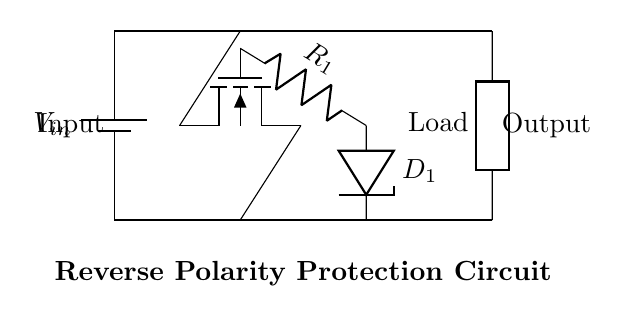What components are used in this circuit? The circuit includes a battery, an N-channel MOSFET (with no body diode), a resistor, a Zener diode, and a generic load.
Answer: Battery, MOSFET, Resistor, Zener diode, Load What is the function of the Zener diode in this circuit? The Zener diode stabilizes the output voltage by allowing current to flow in the reverse direction when the voltage exceeds a certain level, protecting the load from overvoltage.
Answer: Voltage stabilization What is the polarity of the input voltage in this circuit? The input voltage should be connected in a specific direction that allows the MOSFET to conduct; if reversed, the circuit is protected against damage.
Answer: Positive How does the MOSFET protect against reverse polarity? The N-channel MOSFET only allows current to flow in one direction when the gate is activated, thereby blocking any current if the input is connected with reverse polarity, protecting the load.
Answer: By blocking current What happens to the load if the input voltage is reversed? If the input voltage is reversed, the MOSFET remains off, preventing any current from flowing to the load and thereby protecting it from damage.
Answer: No current flows 